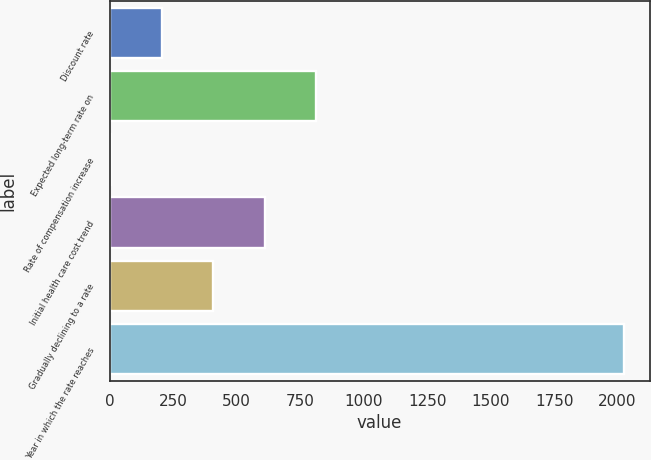Convert chart to OTSL. <chart><loc_0><loc_0><loc_500><loc_500><bar_chart><fcel>Discount rate<fcel>Expected long-term rate on<fcel>Rate of compensation increase<fcel>Initial health care cost trend<fcel>Gradually declining to a rate<fcel>Year in which the rate reaches<nl><fcel>205.81<fcel>812.2<fcel>3.68<fcel>610.07<fcel>407.94<fcel>2025<nl></chart> 